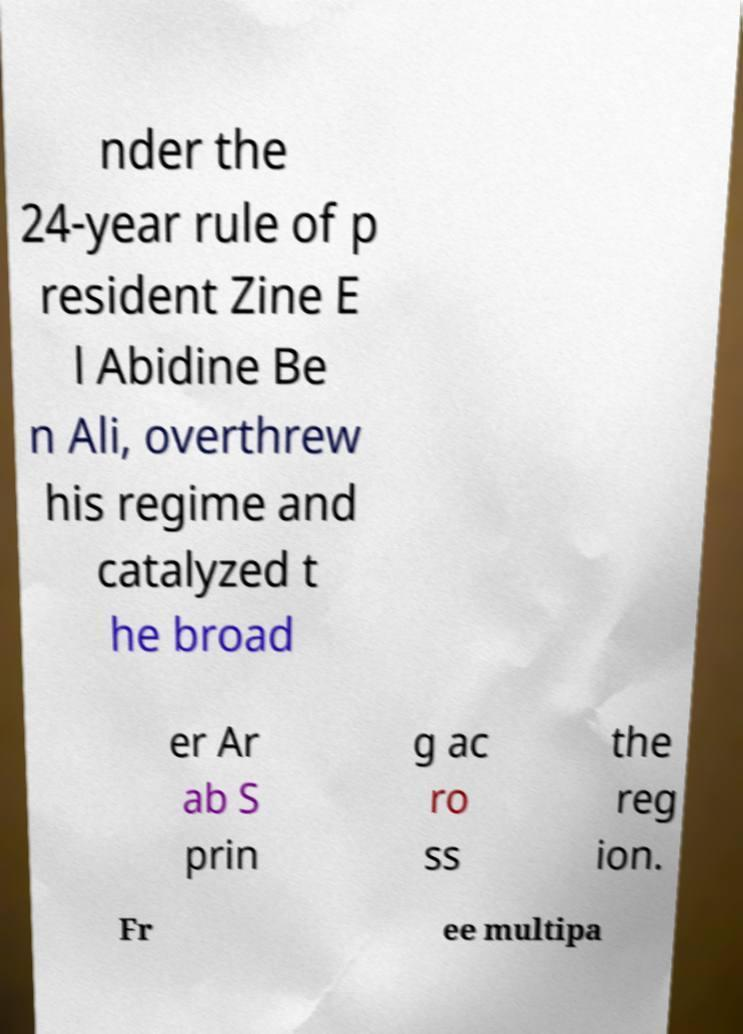Can you read and provide the text displayed in the image?This photo seems to have some interesting text. Can you extract and type it out for me? nder the 24-year rule of p resident Zine E l Abidine Be n Ali, overthrew his regime and catalyzed t he broad er Ar ab S prin g ac ro ss the reg ion. Fr ee multipa 